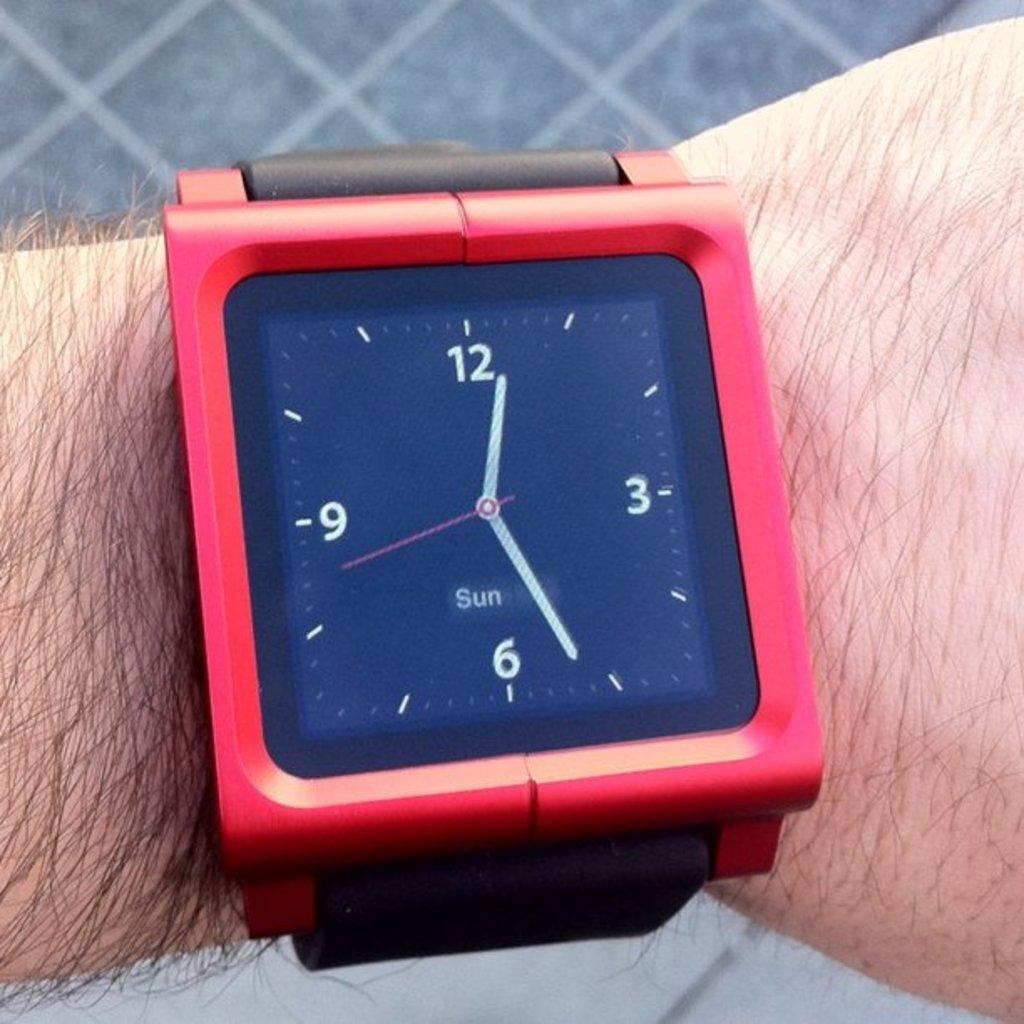What day is it?
Offer a very short reply. Sunday. What time is it?
Provide a short and direct response. 12:26. 